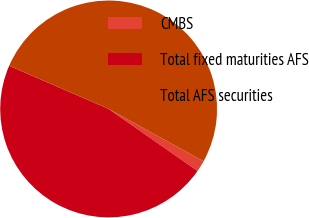Convert chart to OTSL. <chart><loc_0><loc_0><loc_500><loc_500><pie_chart><fcel>CMBS<fcel>Total fixed maturities AFS<fcel>Total AFS securities<nl><fcel>1.68%<fcel>46.82%<fcel>51.5%<nl></chart> 